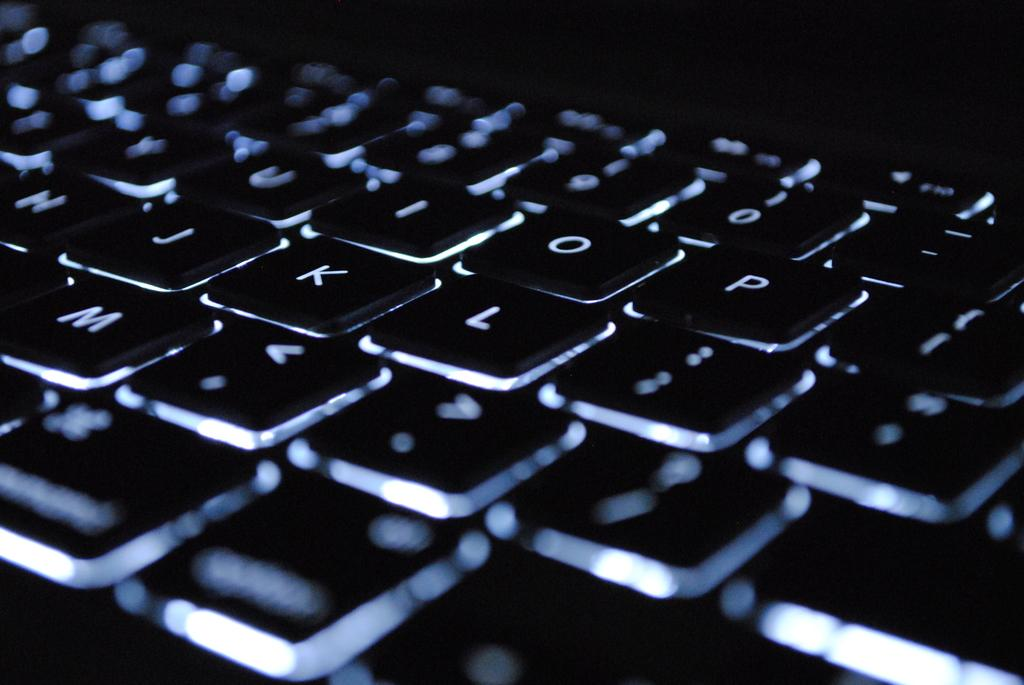Provide a one-sentence caption for the provided image. A keyboard showing the letters Y, U, I, O, P, H, J, K, L, and M. 